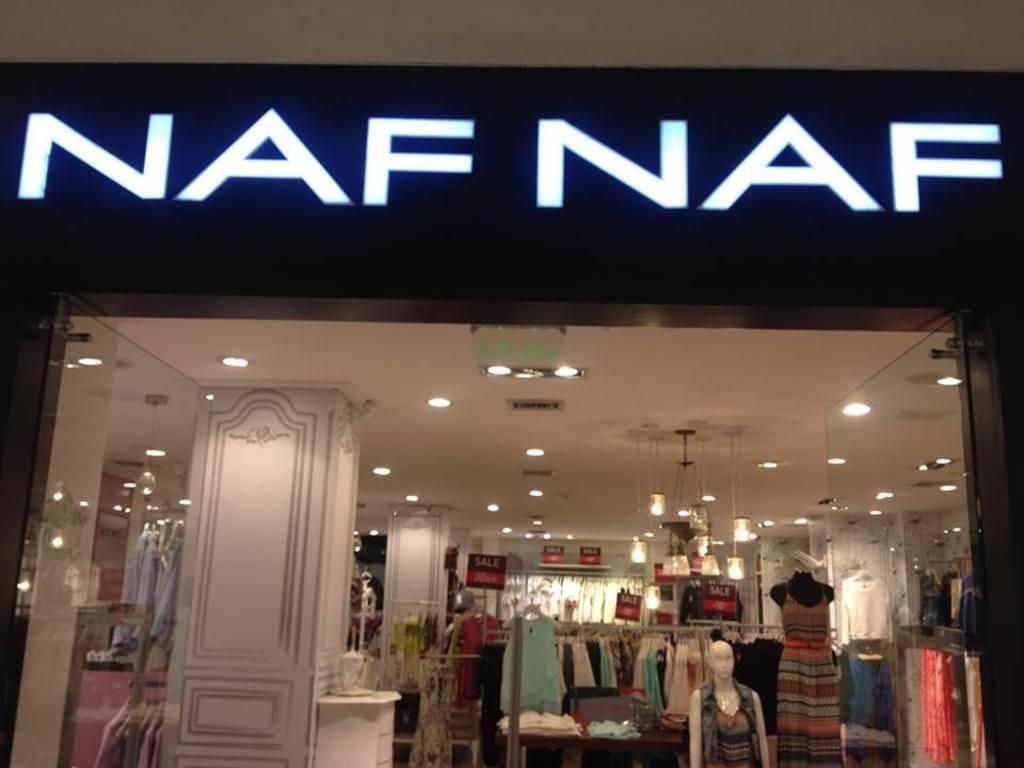What type of store is depicted in the image? There is a cloth store in the image. What can be found inside the store? There are clothes in the store. Are there any display items in the store? Yes, there are mannequins in the store. What type of vegetable is being sold in the cloth store? There are no vegetables being sold in the cloth store; it is a store that sells clothes. What song is playing in the background of the cloth store? There is no information about any music or song playing in the cloth store. 